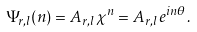<formula> <loc_0><loc_0><loc_500><loc_500>\Psi _ { r , l } ( n ) = A _ { r , l } \chi ^ { n } = A _ { r , l } e ^ { i n \theta } .</formula> 